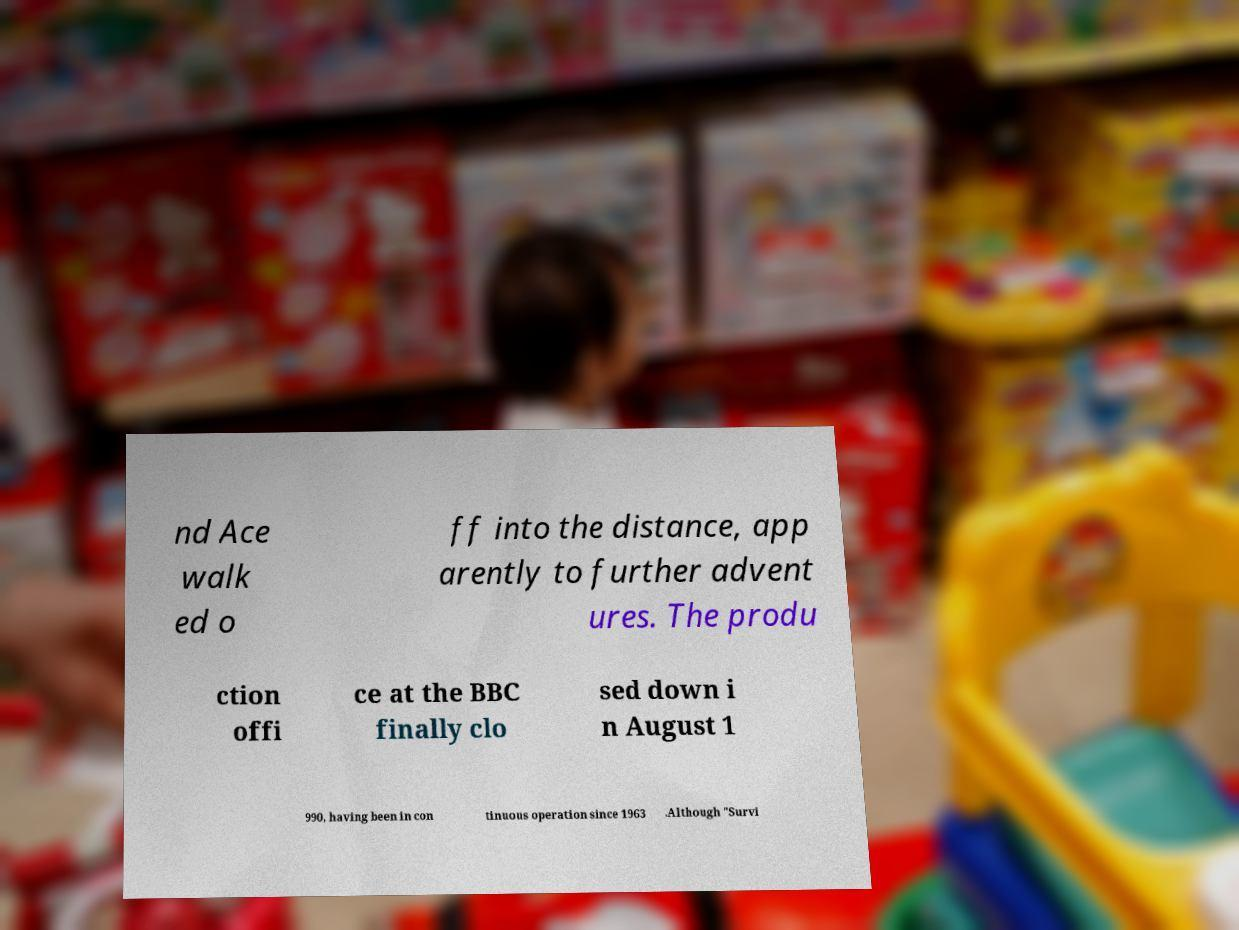Can you read and provide the text displayed in the image?This photo seems to have some interesting text. Can you extract and type it out for me? nd Ace walk ed o ff into the distance, app arently to further advent ures. The produ ction offi ce at the BBC finally clo sed down i n August 1 990, having been in con tinuous operation since 1963 .Although "Survi 